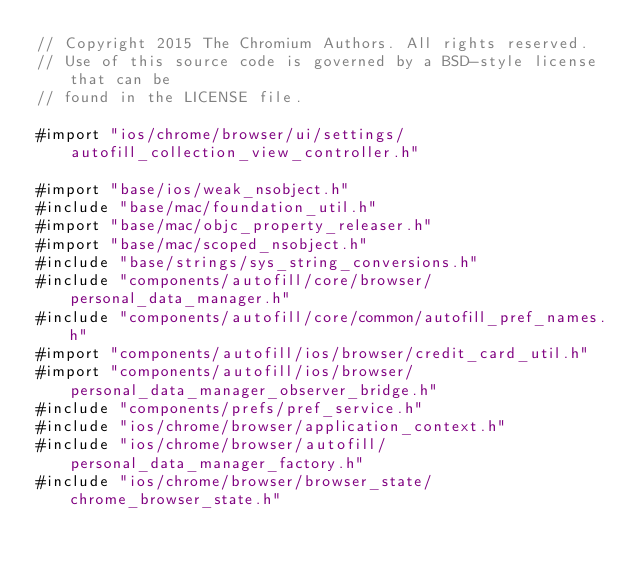<code> <loc_0><loc_0><loc_500><loc_500><_ObjectiveC_>// Copyright 2015 The Chromium Authors. All rights reserved.
// Use of this source code is governed by a BSD-style license that can be
// found in the LICENSE file.

#import "ios/chrome/browser/ui/settings/autofill_collection_view_controller.h"

#import "base/ios/weak_nsobject.h"
#include "base/mac/foundation_util.h"
#import "base/mac/objc_property_releaser.h"
#import "base/mac/scoped_nsobject.h"
#include "base/strings/sys_string_conversions.h"
#include "components/autofill/core/browser/personal_data_manager.h"
#include "components/autofill/core/common/autofill_pref_names.h"
#import "components/autofill/ios/browser/credit_card_util.h"
#import "components/autofill/ios/browser/personal_data_manager_observer_bridge.h"
#include "components/prefs/pref_service.h"
#include "ios/chrome/browser/application_context.h"
#include "ios/chrome/browser/autofill/personal_data_manager_factory.h"
#include "ios/chrome/browser/browser_state/chrome_browser_state.h"</code> 